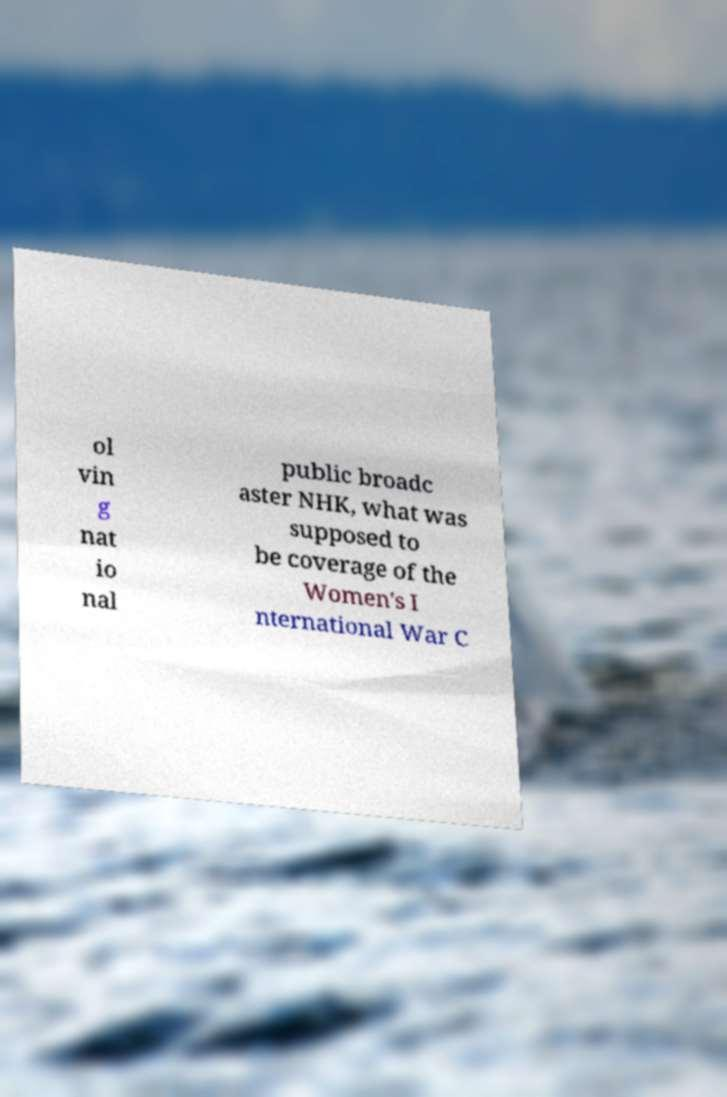Please identify and transcribe the text found in this image. ol vin g nat io nal public broadc aster NHK, what was supposed to be coverage of the Women's I nternational War C 